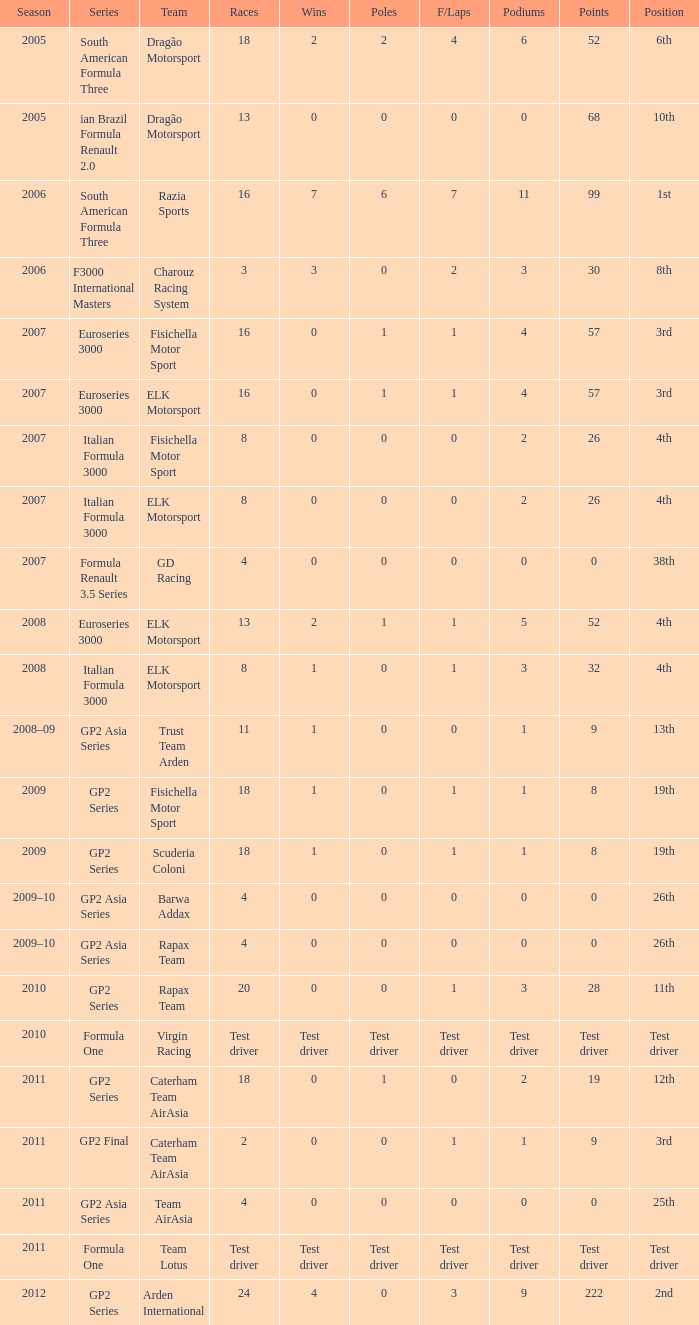How many racing events did he take part in during the year he accumulated 8 points? 18, 18. 